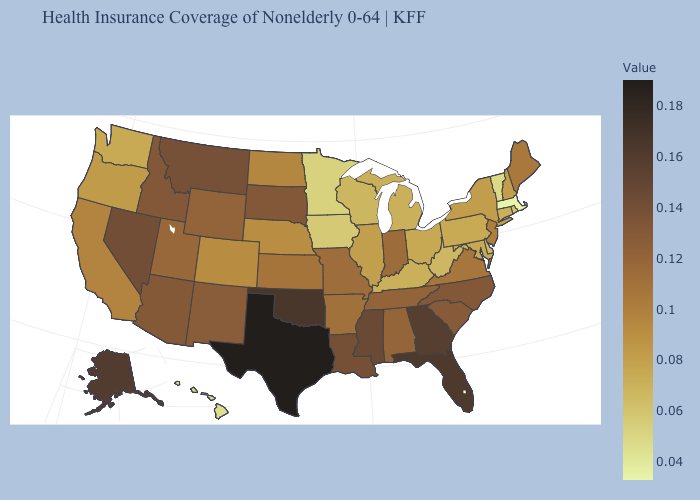Which states hav the highest value in the Northeast?
Give a very brief answer. Maine. Does the map have missing data?
Short answer required. No. 